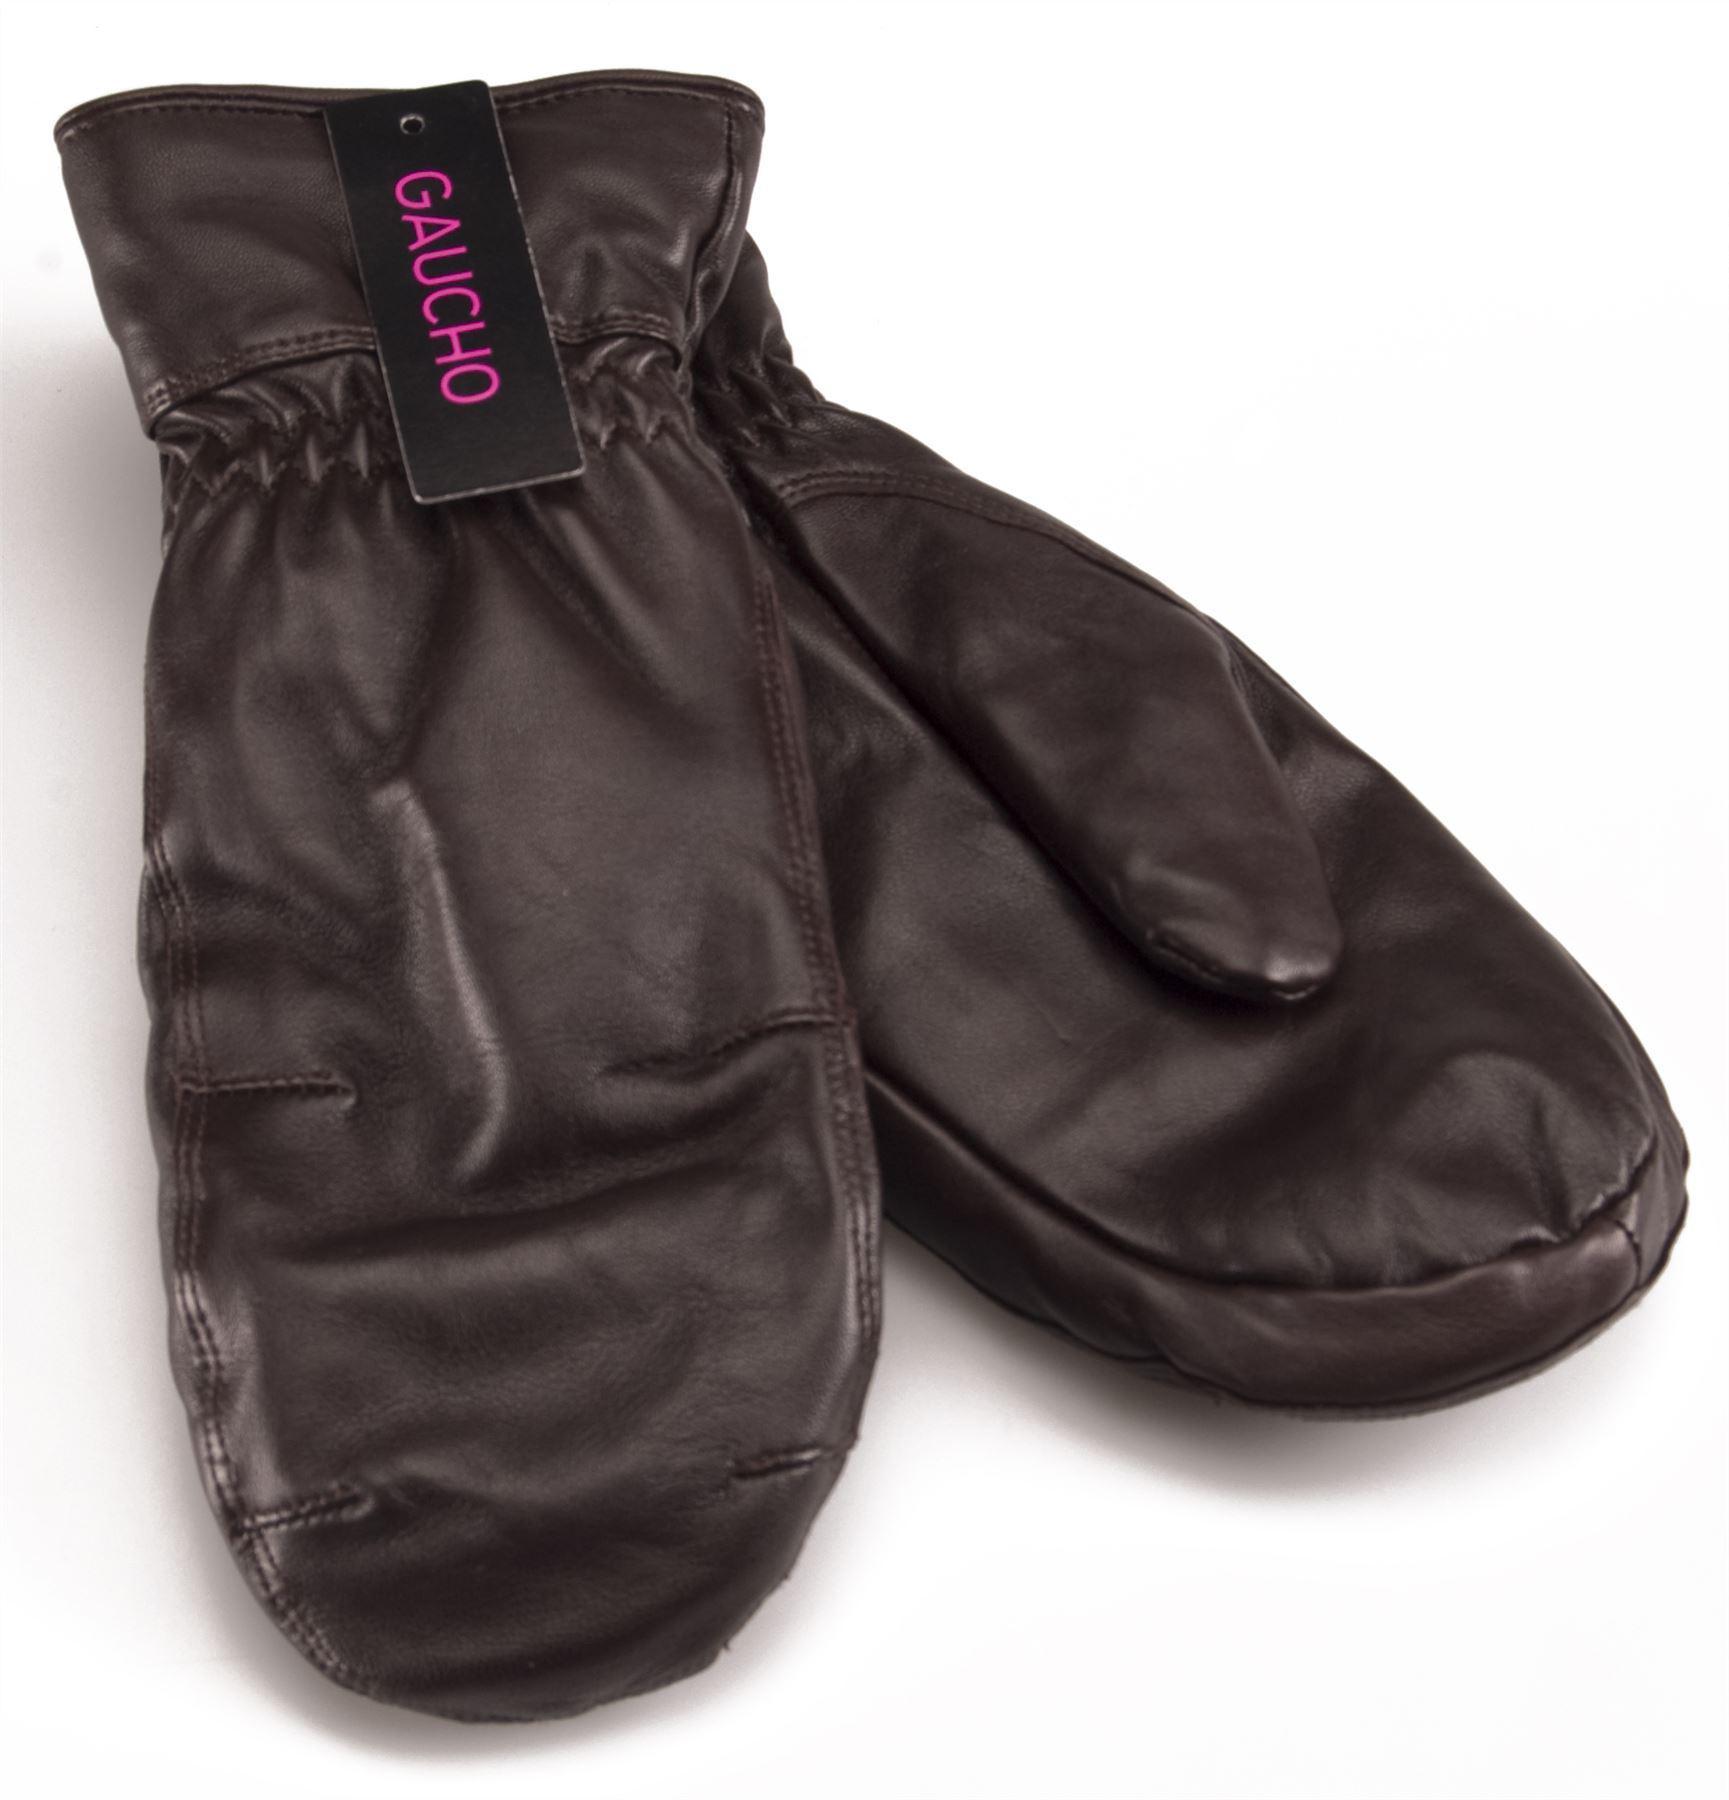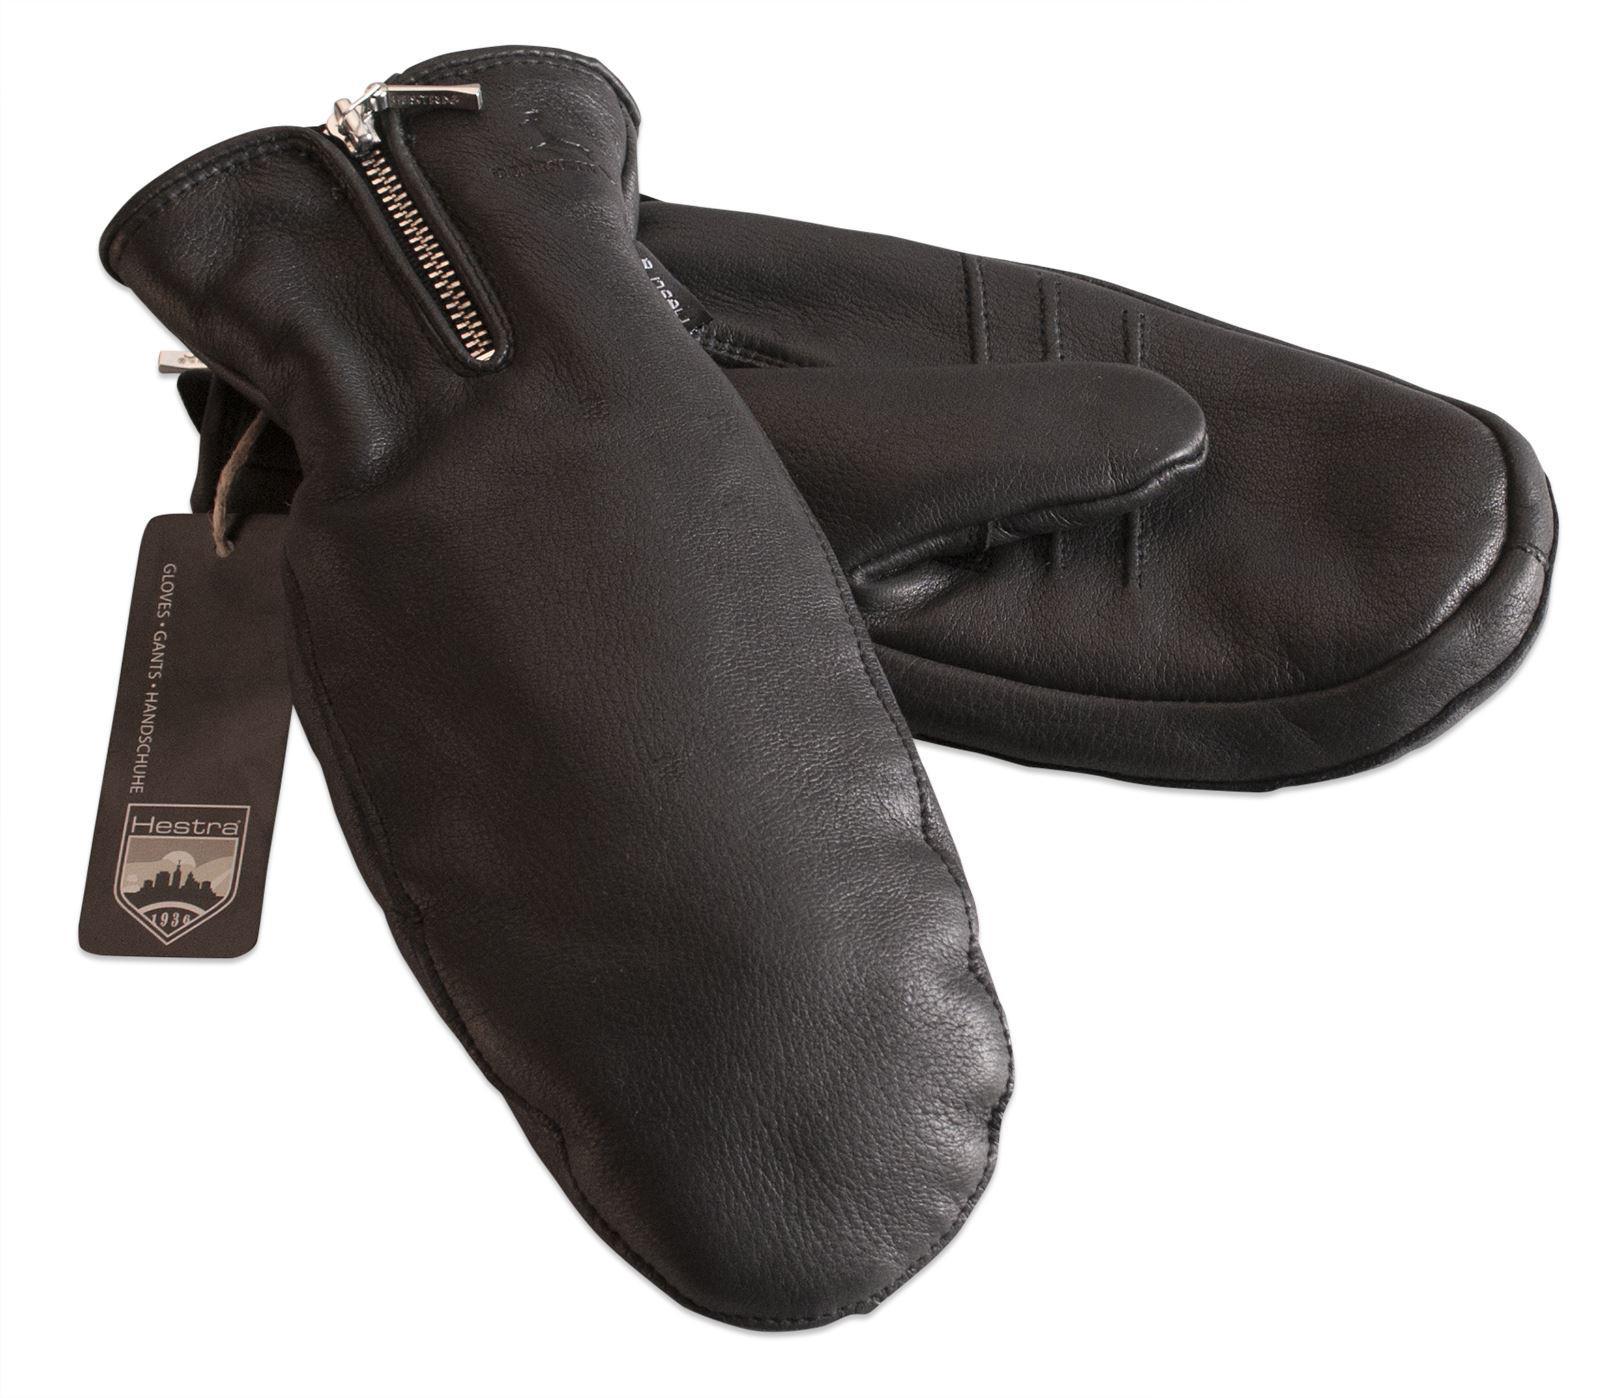The first image is the image on the left, the second image is the image on the right. Given the left and right images, does the statement "Each image shows exactly two mittens, and each pair of mittens is displayed with the two mittens overlapping." hold true? Answer yes or no. Yes. The first image is the image on the left, the second image is the image on the right. For the images shown, is this caption "One pair of dark brown leather mittens has elastic gathering around the wrists, and is displayed angled with one mitten facing each way." true? Answer yes or no. Yes. 